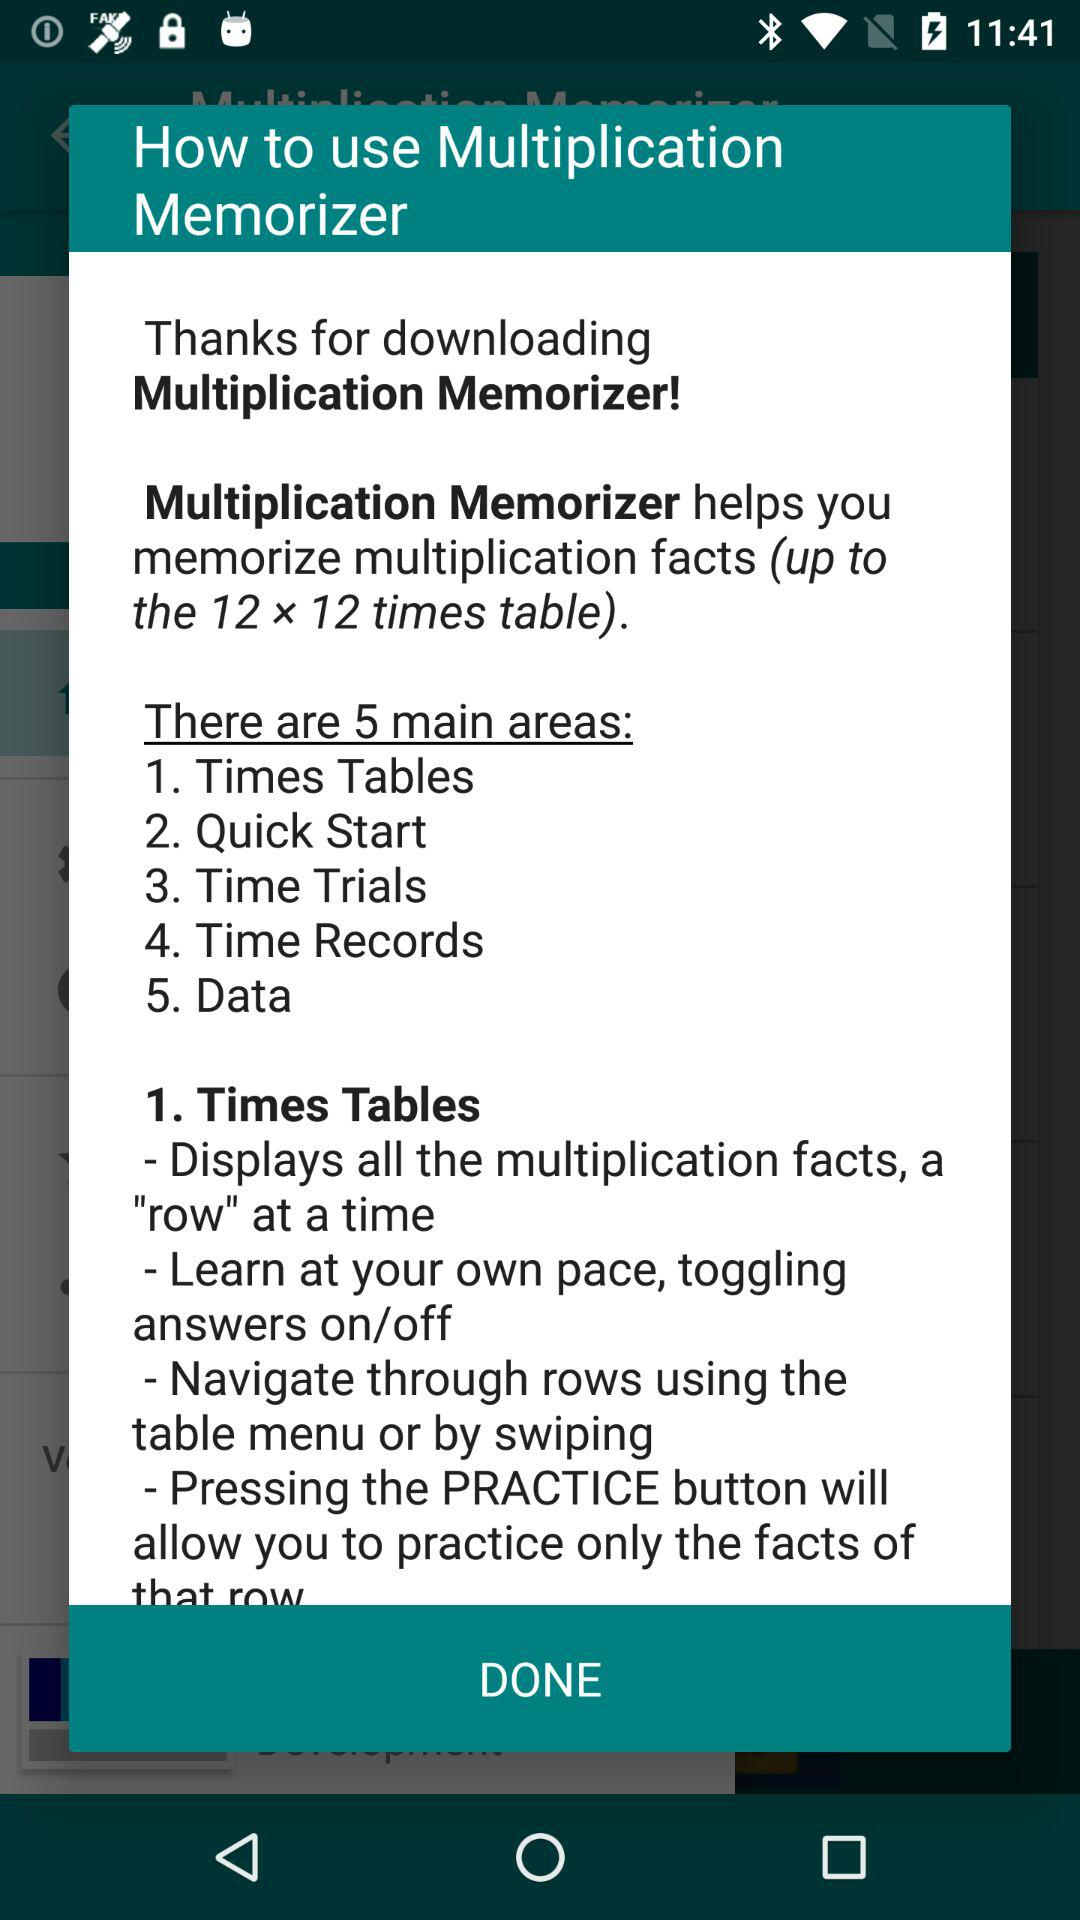How many main areas are there in the app?
Answer the question using a single word or phrase. 5 